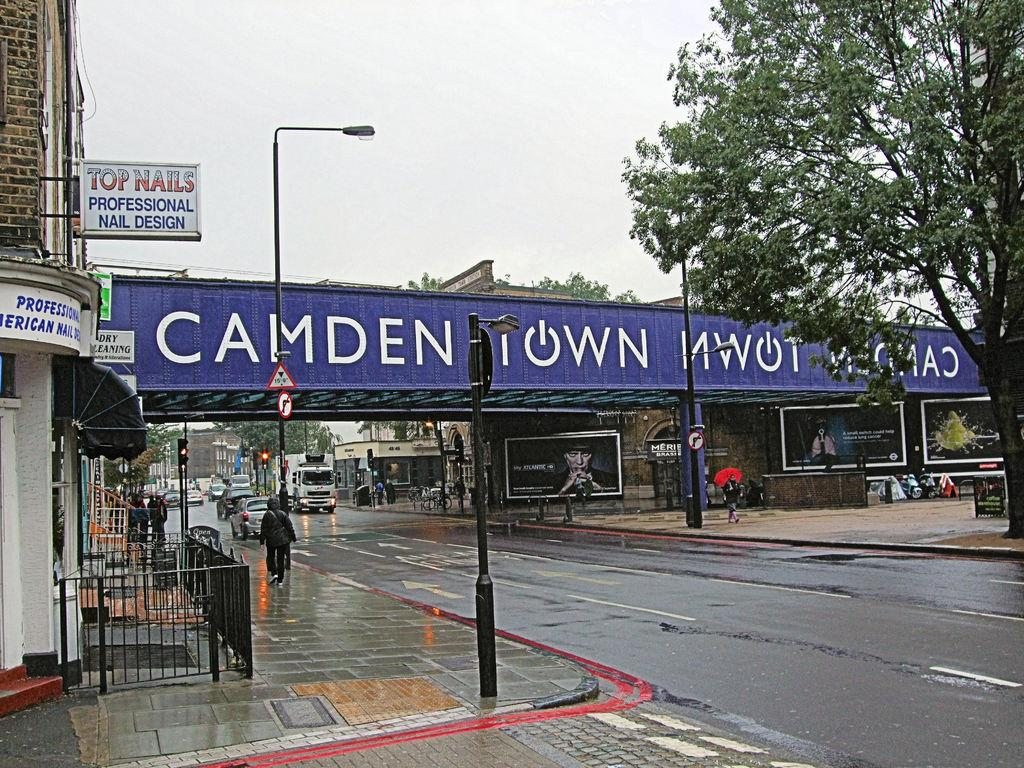What type of road is shown in the image? The image contains a freeway. Are there any structures near the freeway? Yes, there are buildings near the freeway. What type of vegetation can be seen in the image? There is a tree in the image. What is moving on the freeway? Cars are present on the freeway. What else can be seen in the image besides the freeway and cars? Poles and posters are visible in the image. How many babies are visible in the image? There are no babies present in the image. What type of needle is being used to sew the posters in the image? There is no needle present in the image, and the posters are not being sewn. 